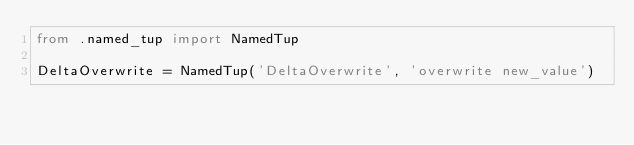<code> <loc_0><loc_0><loc_500><loc_500><_Python_>from .named_tup import NamedTup

DeltaOverwrite = NamedTup('DeltaOverwrite', 'overwrite new_value')
</code> 